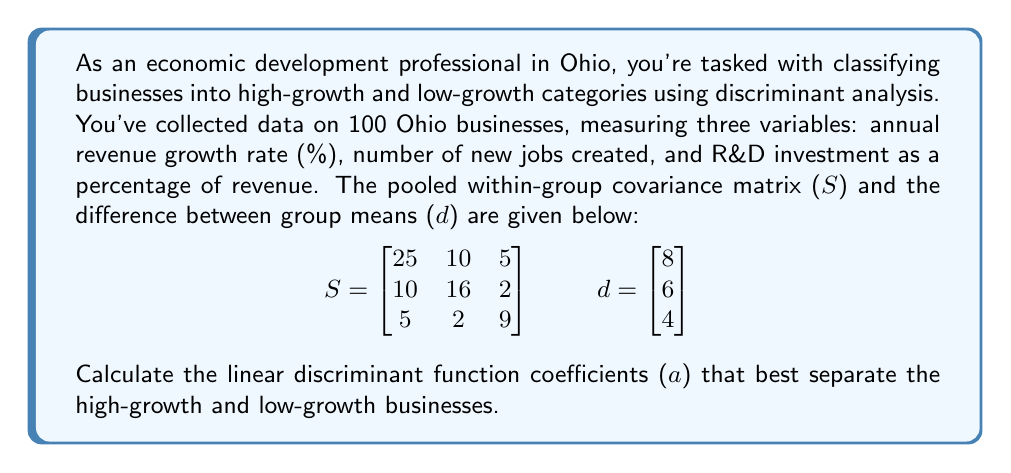Give your solution to this math problem. To solve this problem, we'll use the formula for the linear discriminant function coefficients:

$$a = S^{-1}d$$

Where:
- $S$ is the pooled within-group covariance matrix
- $d$ is the difference between group means
- $a$ is the vector of linear discriminant function coefficients

Steps to solve:

1. First, we need to find the inverse of the covariance matrix $S$.

$$S^{-1} = \begin{bmatrix}
0.0477 & -0.0280 & -0.0280 \\
-0.0280 & 0.0745 & 0.0047 \\
-0.0280 & 0.0047 & 0.1242
\end{bmatrix}$$

2. Now, we multiply $S^{-1}$ by $d$:

$$a = S^{-1}d = \begin{bmatrix}
0.0477 & -0.0280 & -0.0280 \\
-0.0280 & 0.0745 & 0.0047 \\
-0.0280 & 0.0047 & 0.1242
\end{bmatrix} \times \begin{bmatrix}
8 \\
6 \\
4
\end{bmatrix}$$

3. Perform the matrix multiplication:

$$a = \begin{bmatrix}
(0.0477 \times 8) + (-0.0280 \times 6) + (-0.0280 \times 4) \\
(-0.0280 \times 8) + (0.0745 \times 6) + (0.0047 \times 4) \\
(-0.0280 \times 8) + (0.0047 \times 6) + (0.1242 \times 4)
\end{bmatrix}$$

4. Calculate the final values:

$$a = \begin{bmatrix}
0.1816 \\
0.2242 \\
0.2816
\end{bmatrix}$$
Answer: The linear discriminant function coefficients are:

$$a = \begin{bmatrix}
0.1816 \\
0.2242 \\
0.2816
\end{bmatrix}$$ 